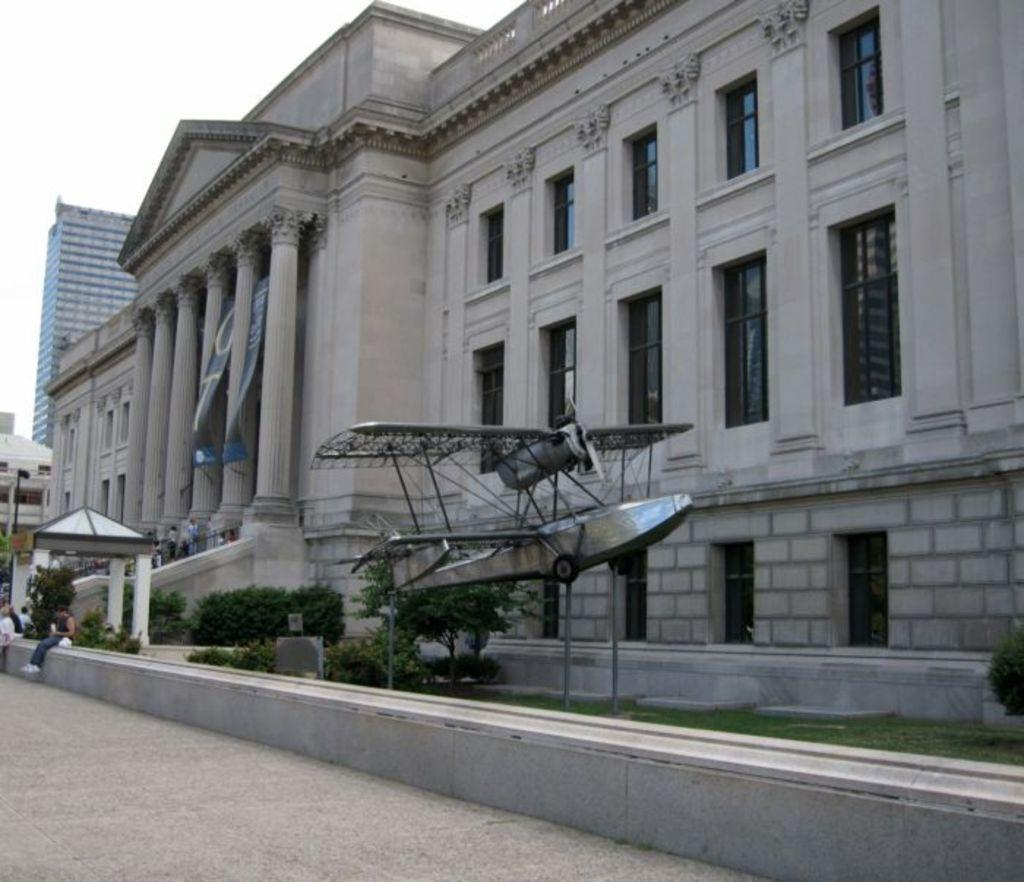What type of structures can be seen in the image? There are buildings in the image. Where are the persons located in the image? The persons are standing on a staircase in the image. What feature is present to provide safety on the staircase? Railings are present in the image. What type of vegetation can be seen in the image? Bushes and trees are present in the image. What artistic object is visible in the image? There is a sculpture in the image. What architectural feature allows light to enter the buildings? Windows are visible in the image. What part of the natural environment is visible in the image? The sky is visible in the image. Can you describe the seating arrangement of a person in the image? There is a person sitting on a wall in the image. What type of volleyball game is being played in the image? There is no volleyball game present in the image. What type of punishment is being administered to the person sitting on the wall in the image? There is no punishment being administered in the image; the person is simply sitting on the wall. 